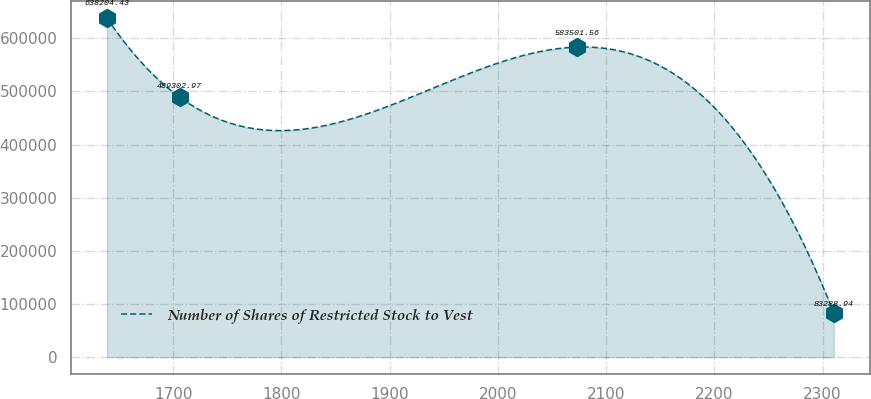<chart> <loc_0><loc_0><loc_500><loc_500><line_chart><ecel><fcel>Number of Shares of Restricted Stock to Vest<nl><fcel>1638.64<fcel>638204<nl><fcel>1705.82<fcel>489303<nl><fcel>2073<fcel>583502<nl><fcel>2310.45<fcel>83288.9<nl></chart> 